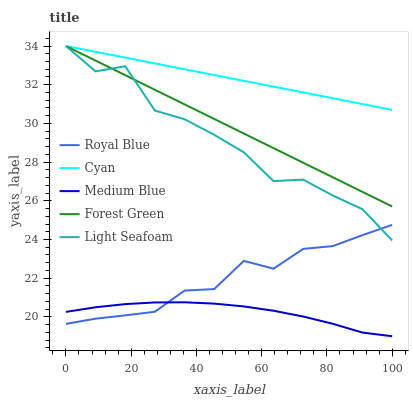Does Medium Blue have the minimum area under the curve?
Answer yes or no. Yes. Does Cyan have the maximum area under the curve?
Answer yes or no. Yes. Does Forest Green have the minimum area under the curve?
Answer yes or no. No. Does Forest Green have the maximum area under the curve?
Answer yes or no. No. Is Forest Green the smoothest?
Answer yes or no. Yes. Is Light Seafoam the roughest?
Answer yes or no. Yes. Is Light Seafoam the smoothest?
Answer yes or no. No. Is Forest Green the roughest?
Answer yes or no. No. Does Medium Blue have the lowest value?
Answer yes or no. Yes. Does Forest Green have the lowest value?
Answer yes or no. No. Does Cyan have the highest value?
Answer yes or no. Yes. Does Medium Blue have the highest value?
Answer yes or no. No. Is Royal Blue less than Forest Green?
Answer yes or no. Yes. Is Cyan greater than Royal Blue?
Answer yes or no. Yes. Does Light Seafoam intersect Forest Green?
Answer yes or no. Yes. Is Light Seafoam less than Forest Green?
Answer yes or no. No. Is Light Seafoam greater than Forest Green?
Answer yes or no. No. Does Royal Blue intersect Forest Green?
Answer yes or no. No. 